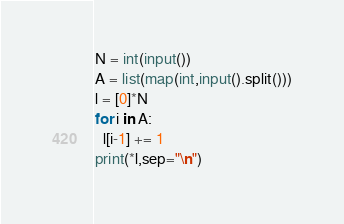Convert code to text. <code><loc_0><loc_0><loc_500><loc_500><_Python_>N = int(input())
A = list(map(int,input().split()))
l = [0]*N
for i in A:
  l[i-1] += 1
print(*l,sep="\n")</code> 